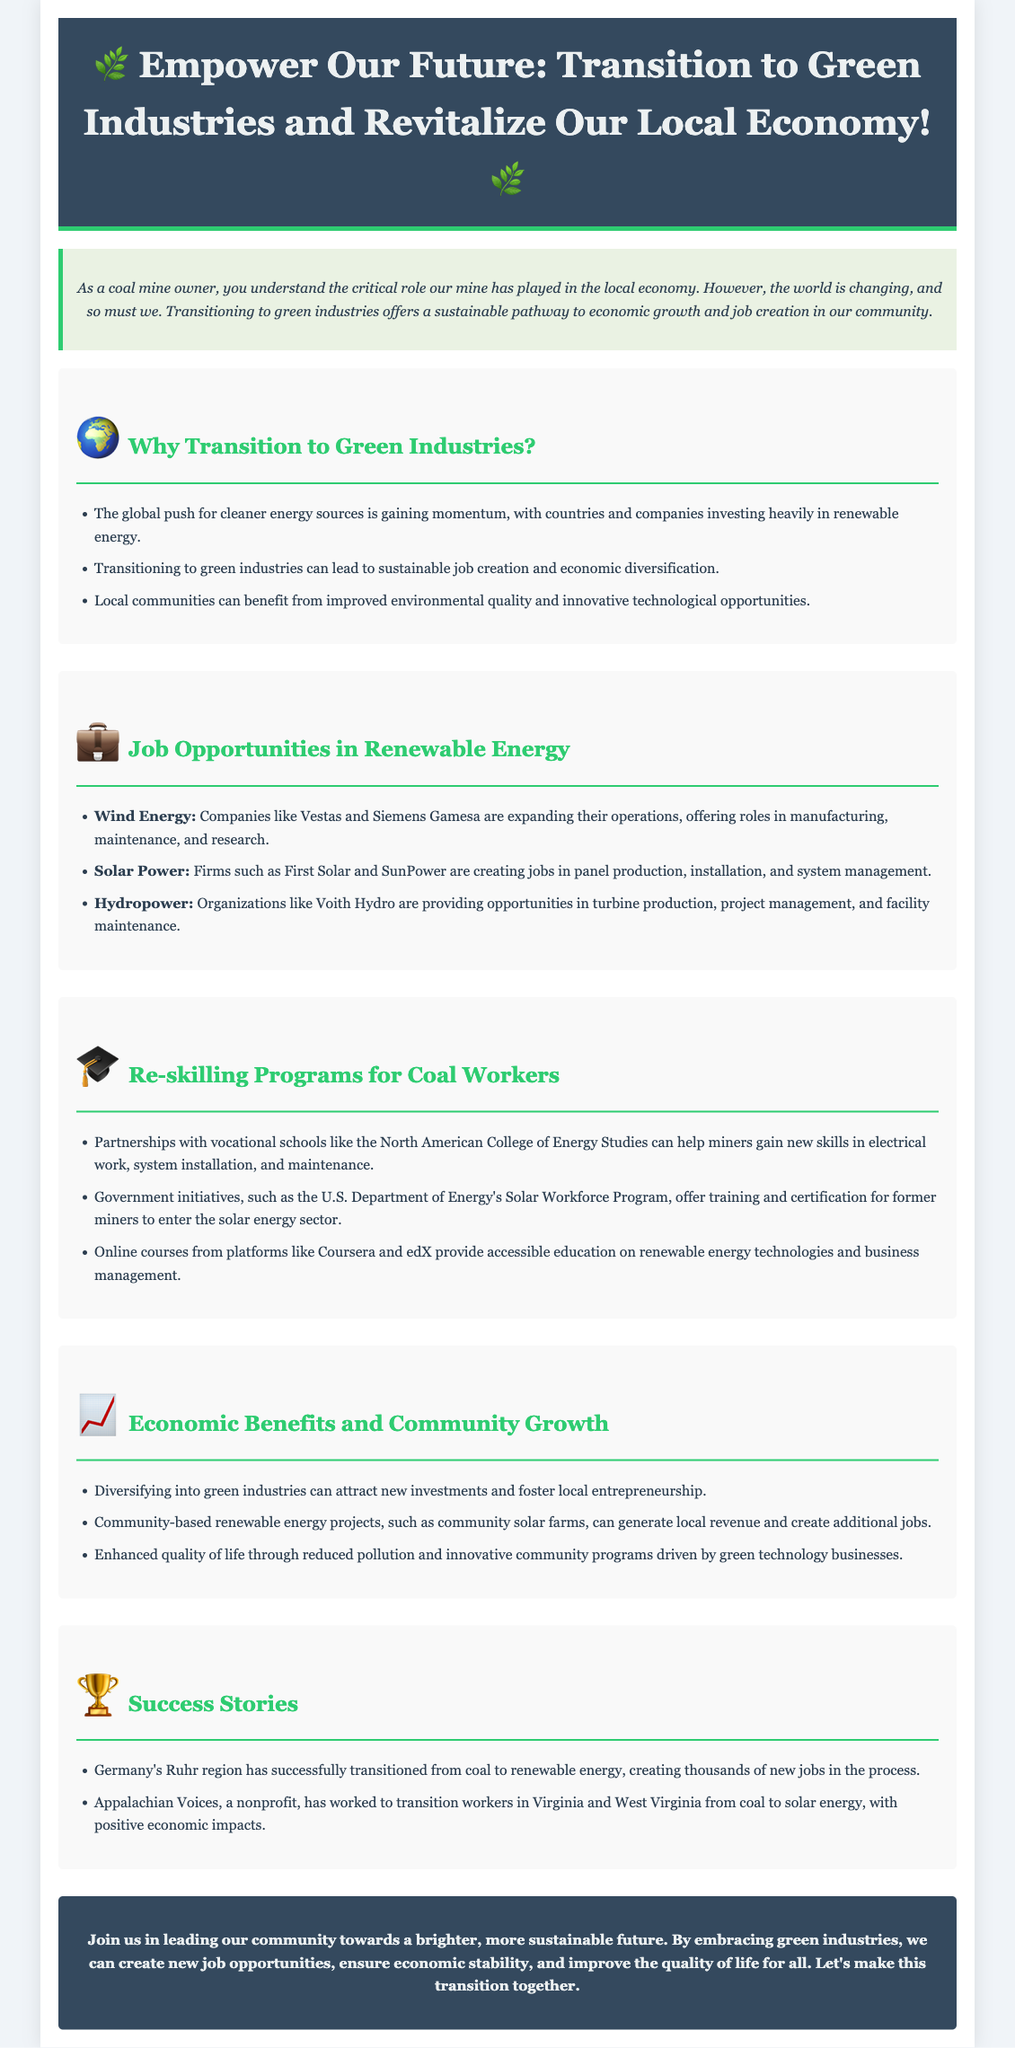What are the three sectors mentioned for job opportunities? The document lists Wind Energy, Solar Power, and Hydropower as the three sectors providing job opportunities.
Answer: Wind Energy, Solar Power, Hydropower What organization offers training for solar energy jobs? The U.S. Department of Energy's Solar Workforce Program is mentioned as a training initiative for former miners entering the solar energy sector.
Answer: U.S. Department of Energy's Solar Workforce Program How many success stories are highlighted in the document? The document mentions two success stories of regions transitioning from coal to renewable energy.
Answer: Two What is the main color of the header background? The header background color is specified as a dark shade, identified in the document as #34495e.
Answer: #34495e What is one economic benefit of transitioning to green industries? The document states that diversifying can attract new investments and foster local entrepreneurship as an economic benefit.
Answer: Attract new investments What type of programs does the document suggest for reskilling? The document suggests vocational schools and online courses as types of programs for reskilling coal workers.
Answer: Vocational schools and online courses What is the title of the advertisement? The title of the advertisement is given clearly at the beginning in a large font.
Answer: Empower Our Future: Transition to Green Industries and Revitalize Our Local Economy What is mentioned as a benefit of community-based renewable energy projects? The document mentions that they can generate local revenue and create additional jobs.
Answer: Generate local revenue and create additional jobs What organization is noted for transitioning workers in Virginia and West Virginia? Appalachian Voices is the nonprofit organization mentioned in the document focused on transitioning workers.
Answer: Appalachian Voices 